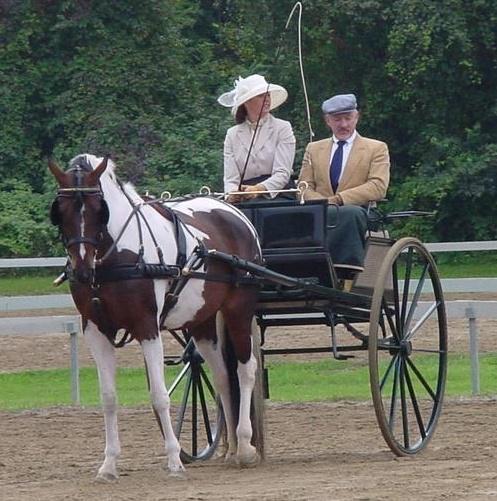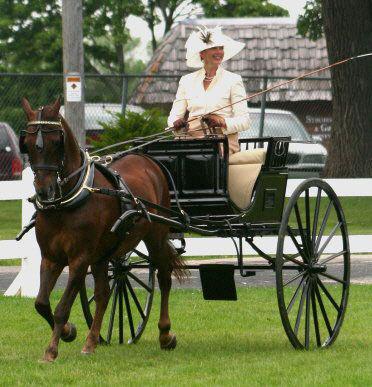The first image is the image on the left, the second image is the image on the right. Examine the images to the left and right. Is the description "On each picture, there is a single horse pulling a cart." accurate? Answer yes or no. Yes. The first image is the image on the left, the second image is the image on the right. Given the left and right images, does the statement "An image shows a four-wheeled wagon pulled by more than one horse." hold true? Answer yes or no. No. 